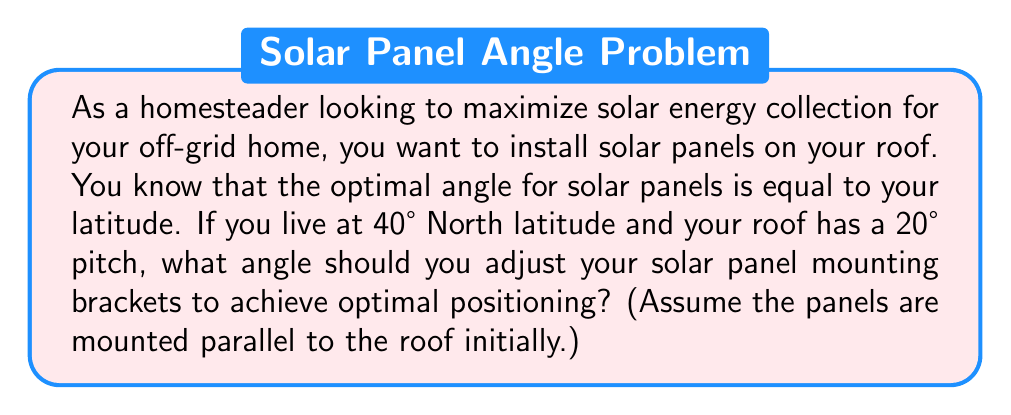Help me with this question. Let's approach this step-by-step using trigonometry:

1. The optimal angle for solar panels is equal to the latitude. In this case, it's 40°.

2. The roof already has a 20° pitch, which means the panels are initially tilted at 20° from horizontal.

3. We need to find the additional angle needed to reach the optimal 40° tilt.

4. Let's define our angles:
   $\theta_{\text{optimal}}$ = 40° (optimal angle)
   $\theta_{\text{roof}}$ = 20° (roof pitch)
   $\theta_{\text{adjustment}}$ = angle needed for adjustment

5. We can set up the equation:
   $$\theta_{\text{optimal}} = \theta_{\text{roof}} + \theta_{\text{adjustment}}$$

6. Substituting the known values:
   $$40° = 20° + \theta_{\text{adjustment}}$$

7. Solving for $\theta_{\text{adjustment}}$:
   $$\theta_{\text{adjustment}} = 40° - 20° = 20°$$

Therefore, the solar panel mounting brackets should be adjusted to add an additional 20° tilt to the panels.

[asy]
unitsize(1cm);
draw((0,0)--(5,0),arrow);
draw((0,0)--(0,3),arrow);
draw((0,0)--(5,1.82));
draw((0,0)--(5,3.73));
label("Horizontal", (5,-0.3));
label("Vertical", (-0.3,3));
label("Roof (20°)", (4,0.5));
label("Solar Panel (40°)", (4,2.5));
label("20°", (0.7,0.3));
label("20°", (0.7,1.5));
[/asy]
Answer: 20° 